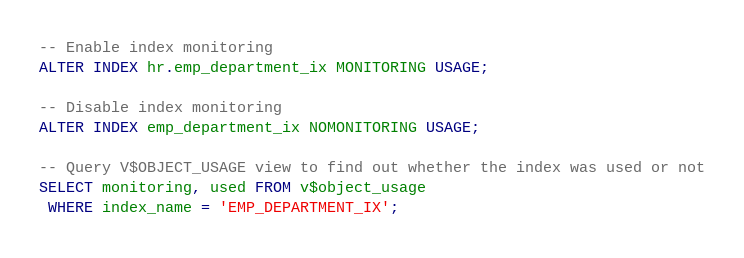Convert code to text. <code><loc_0><loc_0><loc_500><loc_500><_SQL_>-- Enable index monitoring 
ALTER INDEX hr.emp_department_ix MONITORING USAGE;

-- Disable index monitoring
ALTER INDEX emp_department_ix NOMONITORING USAGE;

-- Query V$OBJECT_USAGE view to find out whether the index was used or not
SELECT monitoring, used FROM v$object_usage
 WHERE index_name = 'EMP_DEPARTMENT_IX';
</code> 